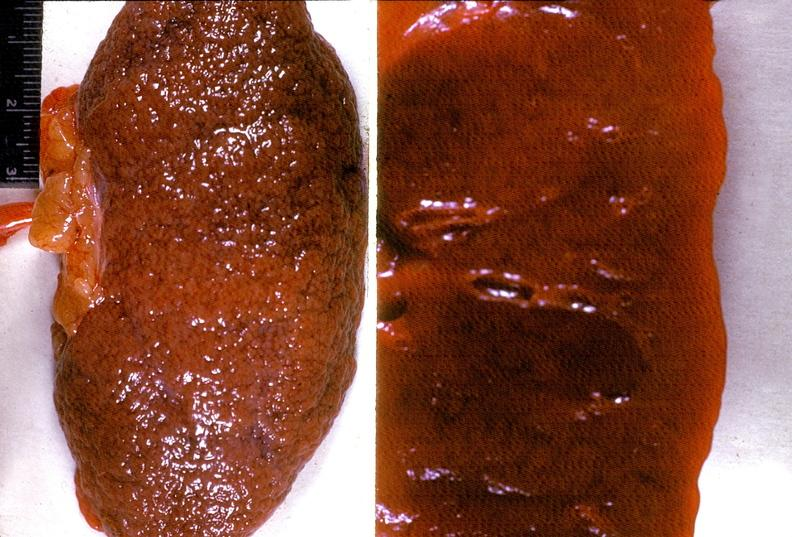does this image show kidney, arteriolonephrosclerosis, malignant hypertension?
Answer the question using a single word or phrase. Yes 